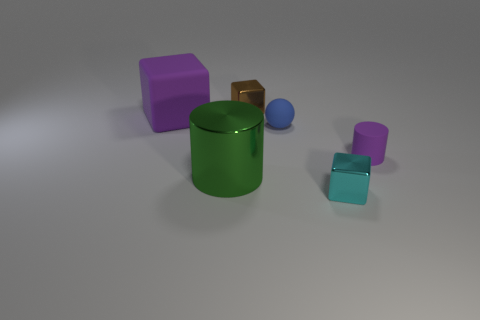How many small things are behind the tiny purple rubber cylinder and in front of the matte cylinder?
Make the answer very short. 0. What size is the brown metallic thing that is the same shape as the cyan object?
Provide a succinct answer. Small. What number of small brown things are behind the matte cylinder that is behind the tiny metal cube in front of the tiny cylinder?
Ensure brevity in your answer.  1. There is a cube behind the matte object that is to the left of the large metallic thing; what is its color?
Ensure brevity in your answer.  Brown. What number of large metallic things are on the right side of the cylinder that is right of the tiny cyan metal block?
Give a very brief answer. 0. Is there anything else that is the same shape as the blue object?
Make the answer very short. No. Is the color of the cylinder right of the tiny cyan object the same as the big object behind the purple cylinder?
Provide a short and direct response. Yes. Are there fewer big cylinders than red metal cylinders?
Your response must be concise. No. There is a shiny object that is in front of the cylinder that is on the left side of the tiny purple object; what shape is it?
Offer a terse response. Cube. What is the shape of the big thing in front of the purple cylinder on the right side of the small cube that is behind the small purple matte thing?
Your answer should be compact. Cylinder. 